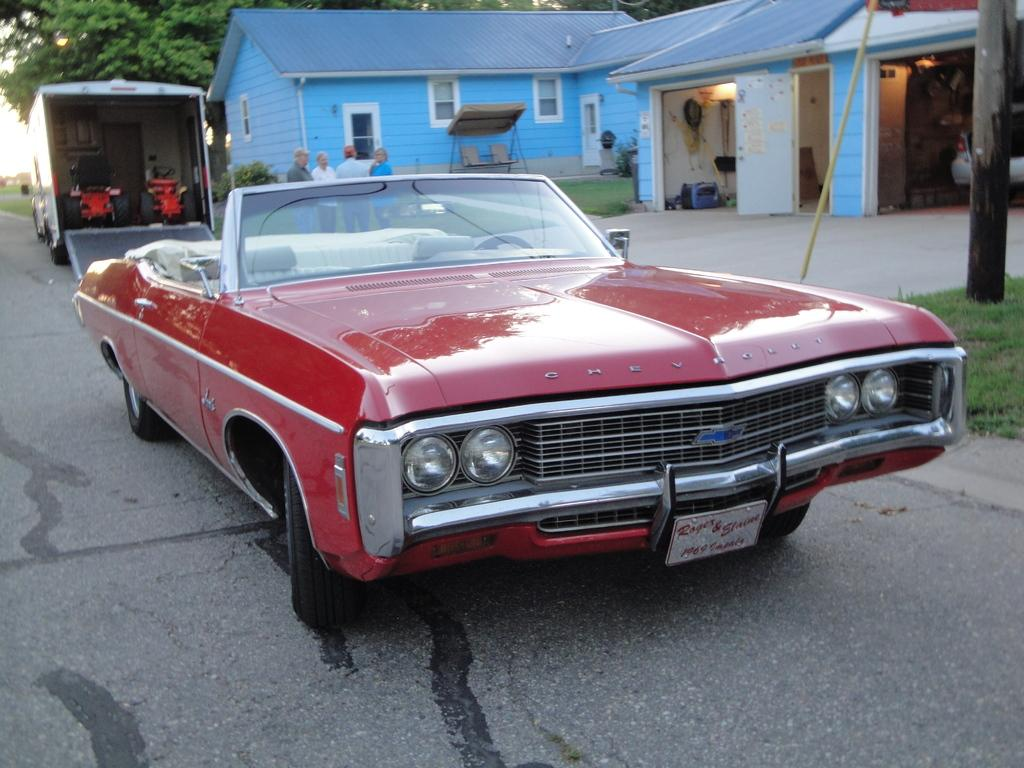What can be seen in the image? There are vehicles in the image. What is visible in the background of the image? There is grass, houses, and trees in the background of the image. Can you describe the group of people in the image? There is there any specific activity they are engaged in? What type of test is being conducted on the bears in the image? There are no bears present in the image, so it is not possible to answer a question about a test being conducted on them. 